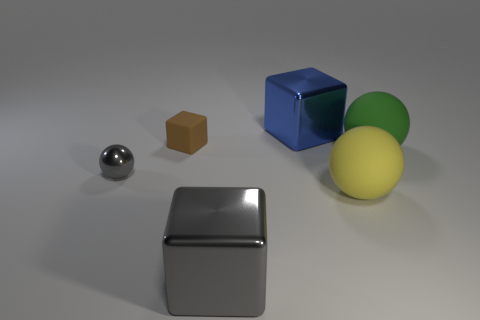Add 2 large cyan matte cylinders. How many objects exist? 8 Subtract 1 gray spheres. How many objects are left? 5 Subtract all small brown things. Subtract all large matte spheres. How many objects are left? 3 Add 3 small brown matte blocks. How many small brown matte blocks are left? 4 Add 4 large things. How many large things exist? 8 